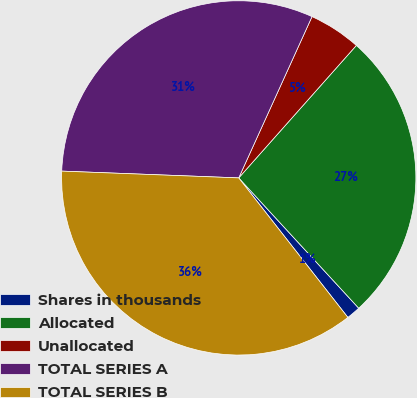Convert chart to OTSL. <chart><loc_0><loc_0><loc_500><loc_500><pie_chart><fcel>Shares in thousands<fcel>Allocated<fcel>Unallocated<fcel>TOTAL SERIES A<fcel>TOTAL SERIES B<nl><fcel>1.28%<fcel>26.6%<fcel>4.77%<fcel>31.18%<fcel>36.18%<nl></chart> 